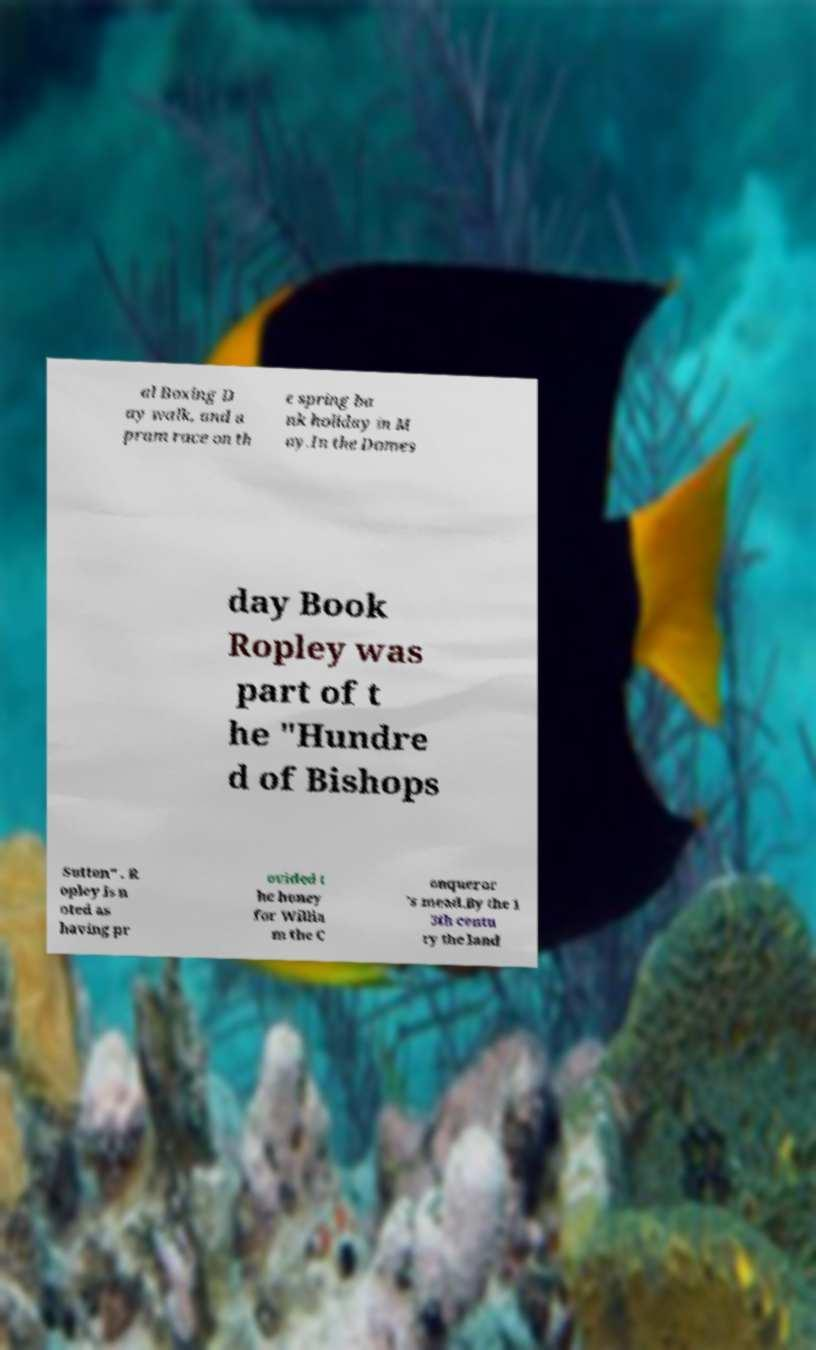What messages or text are displayed in this image? I need them in a readable, typed format. al Boxing D ay walk, and a pram race on th e spring ba nk holiday in M ay.In the Domes day Book Ropley was part of t he "Hundre d of Bishops Sutton" . R opley is n oted as having pr ovided t he honey for Willia m the C onqueror 's mead.By the 1 3th centu ry the land 